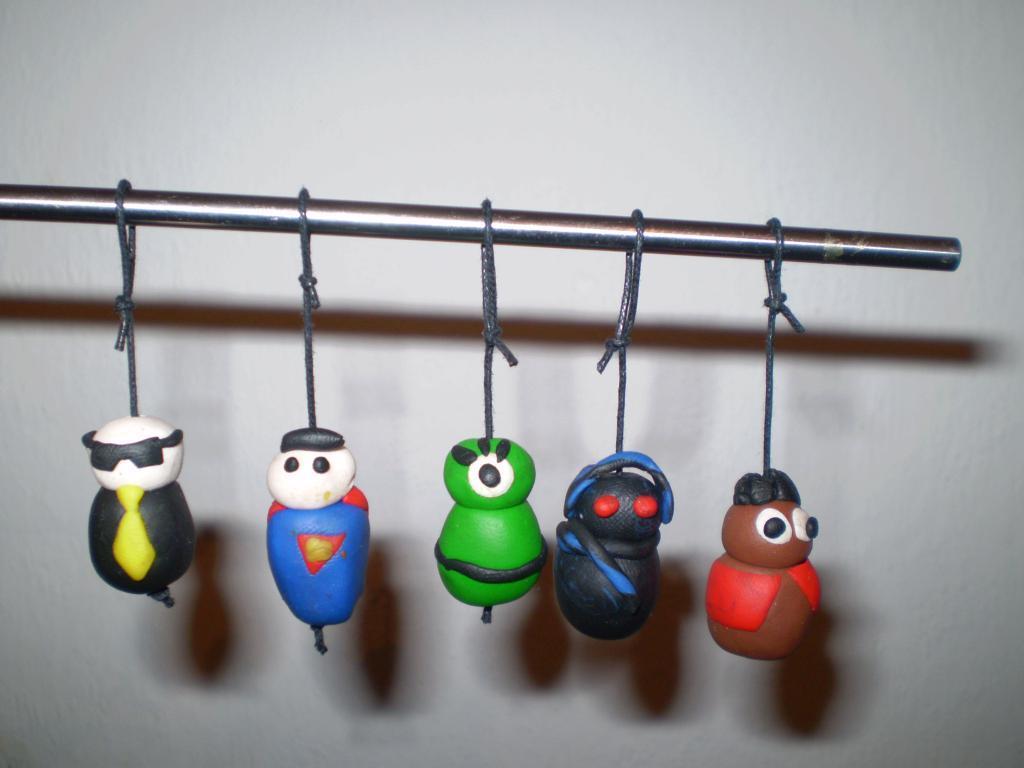How would you summarize this image in a sentence or two? This image consists puppets made with a clay are tied and hanged to a road. All the puppets are in different color. In the background, there is a wall. 